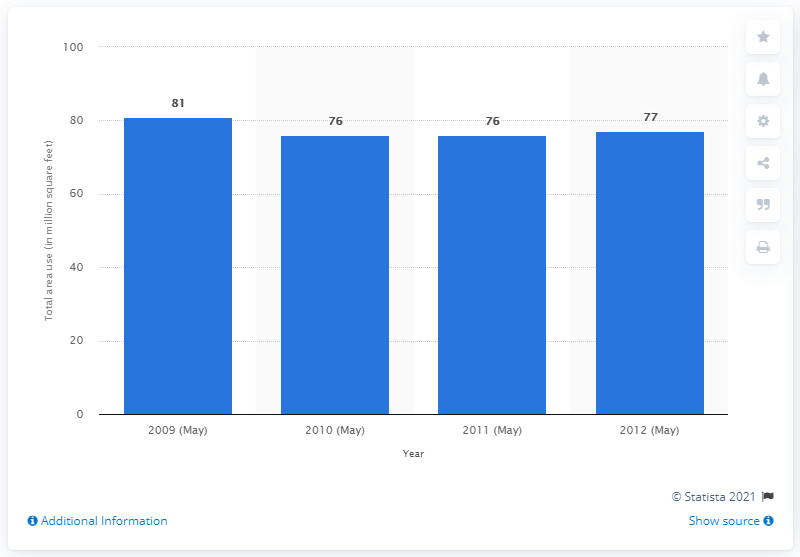Indicate a few pertinent items in this graphic. In 2010, the US spa industry used approximately 76 square feet of land. 